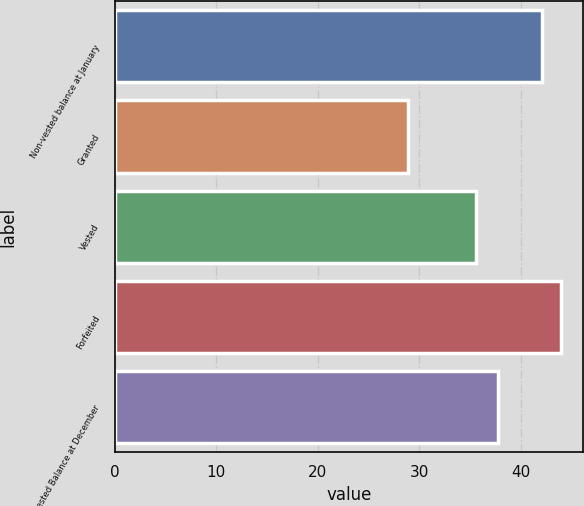<chart> <loc_0><loc_0><loc_500><loc_500><bar_chart><fcel>Non-vested balance at January<fcel>Granted<fcel>Vested<fcel>Forfeited<fcel>Non-vested Balance at December<nl><fcel>42.13<fcel>28.87<fcel>35.57<fcel>43.91<fcel>37.73<nl></chart> 